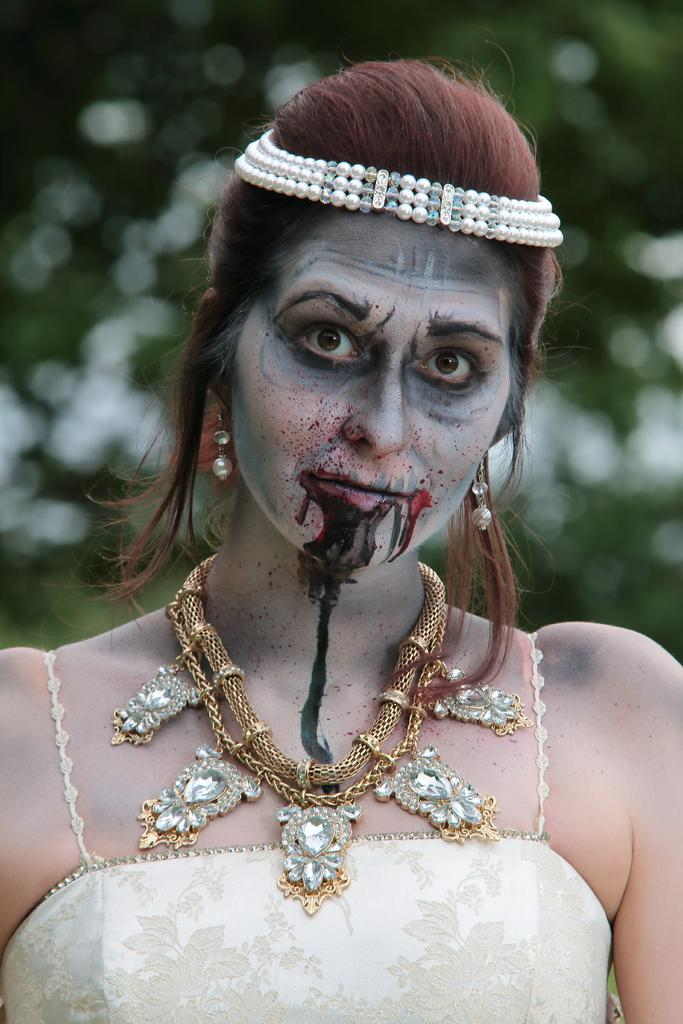Who is present in the image? There is a woman in the image. What is the woman doing in the image? The woman is standing in the image. What accessory is the woman wearing in the image? The woman is wearing a locket in the image. What type of grain is visible in the image? There is no grain present in the image. How many geese are visible in the image? There are no geese present in the image. 